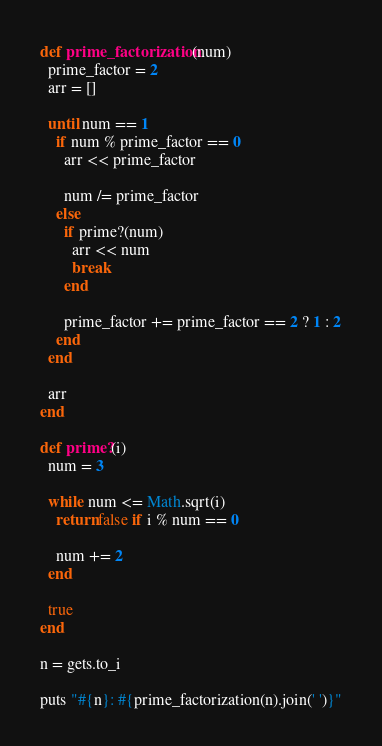<code> <loc_0><loc_0><loc_500><loc_500><_Ruby_>def prime_factorization(num)
  prime_factor = 2
  arr = []

  until num == 1
    if num % prime_factor == 0
      arr << prime_factor

      num /= prime_factor
    else
      if prime?(num)
        arr << num
        break
      end

      prime_factor += prime_factor == 2 ? 1 : 2
    end
  end

  arr
end

def prime?(i)
  num = 3

  while num <= Math.sqrt(i)
    return false if i % num == 0

    num += 2
  end

  true
end

n = gets.to_i

puts "#{n}: #{prime_factorization(n).join(' ')}"</code> 